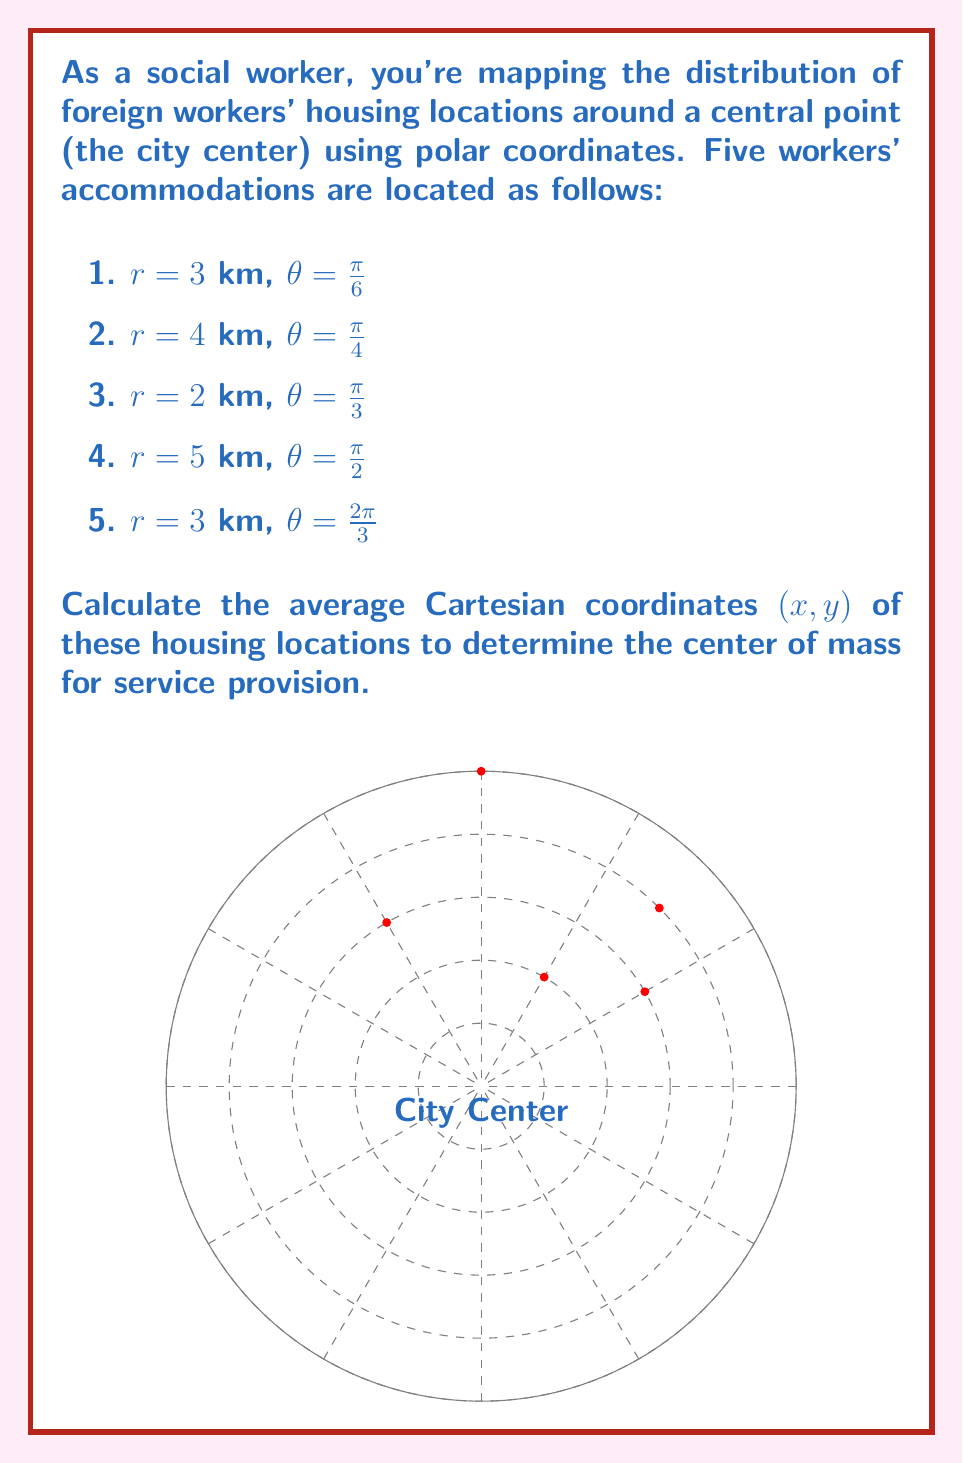Could you help me with this problem? Let's approach this step-by-step:

1) First, we need to convert each polar coordinate $(r, \theta)$ to Cartesian coordinates $(x, y)$ using these formulas:
   $x = r \cos(\theta)$
   $y = r \sin(\theta)$

2) Let's calculate for each point:

   Point 1: $r = 3$, $\theta = \frac{\pi}{6}$
   $x_1 = 3 \cos(\frac{\pi}{6}) = 3 \cdot \frac{\sqrt{3}}{2} = \frac{3\sqrt{3}}{2}$
   $y_1 = 3 \sin(\frac{\pi}{6}) = 3 \cdot \frac{1}{2} = \frac{3}{2}$

   Point 2: $r = 4$, $\theta = \frac{\pi}{4}$
   $x_2 = 4 \cos(\frac{\pi}{4}) = 4 \cdot \frac{\sqrt{2}}{2} = 2\sqrt{2}$
   $y_2 = 4 \sin(\frac{\pi}{4}) = 4 \cdot \frac{\sqrt{2}}{2} = 2\sqrt{2}$

   Point 3: $r = 2$, $\theta = \frac{\pi}{3}$
   $x_3 = 2 \cos(\frac{\pi}{3}) = 2 \cdot \frac{1}{2} = 1$
   $y_3 = 2 \sin(\frac{\pi}{3}) = 2 \cdot \frac{\sqrt{3}}{2} = \sqrt{3}$

   Point 4: $r = 5$, $\theta = \frac{\pi}{2}$
   $x_4 = 5 \cos(\frac{\pi}{2}) = 0$
   $y_4 = 5 \sin(\frac{\pi}{2}) = 5$

   Point 5: $r = 3$, $\theta = \frac{2\pi}{3}$
   $x_5 = 3 \cos(\frac{2\pi}{3}) = 3 \cdot (-\frac{1}{2}) = -\frac{3}{2}$
   $y_5 = 3 \sin(\frac{2\pi}{3}) = 3 \cdot \frac{\sqrt{3}}{2} = \frac{3\sqrt{3}}{2}$

3) Now, to find the average coordinates, we sum up all x-coordinates and y-coordinates separately and divide by the number of points (5):

   $\bar{x} = \frac{x_1 + x_2 + x_3 + x_4 + x_5}{5} = \frac{\frac{3\sqrt{3}}{2} + 2\sqrt{2} + 1 + 0 + (-\frac{3}{2})}{5}$

   $\bar{y} = \frac{y_1 + y_2 + y_3 + y_4 + y_5}{5} = \frac{\frac{3}{2} + 2\sqrt{2} + \sqrt{3} + 5 + \frac{3\sqrt{3}}{2}}{5}$

4) Simplifying:
   $\bar{x} = \frac{3\sqrt{3} + 4\sqrt{2} + 2 - 3}{10} = \frac{3\sqrt{3} + 4\sqrt{2} - 1}{10}$

   $\bar{y} = \frac{3 + 4\sqrt{2} + 2\sqrt{3} + 10 + 3\sqrt{3}}{10} = \frac{13 + 4\sqrt{2} + 5\sqrt{3}}{10}$

Thus, the center of mass is at $(\frac{3\sqrt{3} + 4\sqrt{2} - 1}{10}, \frac{13 + 4\sqrt{2} + 5\sqrt{3}}{10})$.
Answer: $(\frac{3\sqrt{3} + 4\sqrt{2} - 1}{10}, \frac{13 + 4\sqrt{2} + 5\sqrt{3}}{10})$ 